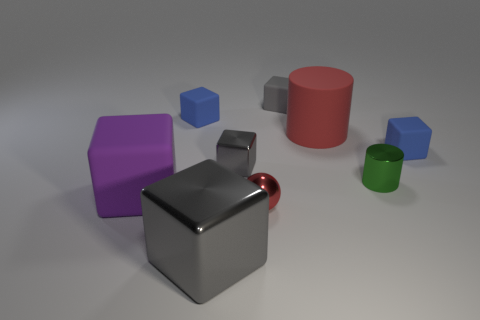Subtract all gray cylinders. How many gray cubes are left? 3 Subtract all blue blocks. How many blocks are left? 4 Subtract all tiny metal cubes. How many cubes are left? 5 Subtract all green cubes. Subtract all brown spheres. How many cubes are left? 6 Subtract all spheres. How many objects are left? 8 Add 6 big yellow balls. How many big yellow balls exist? 6 Subtract 0 yellow blocks. How many objects are left? 9 Subtract all small purple rubber cylinders. Subtract all large purple matte cubes. How many objects are left? 8 Add 6 metal blocks. How many metal blocks are left? 8 